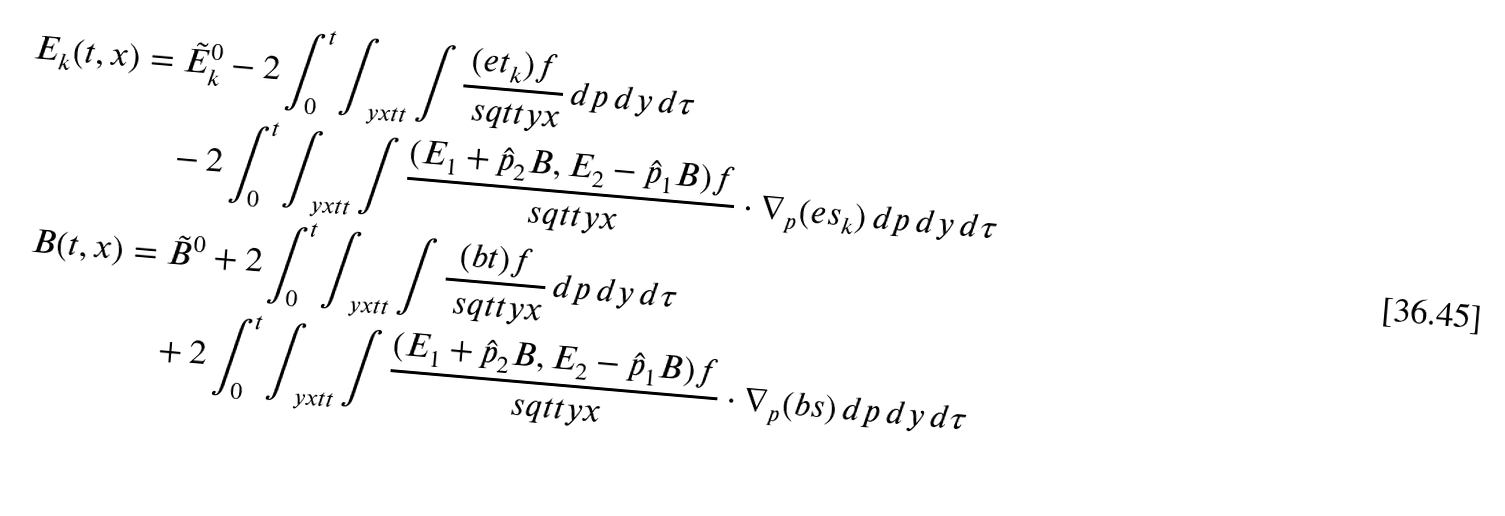<formula> <loc_0><loc_0><loc_500><loc_500>E _ { k } ( t , x ) & = \tilde { E } ^ { 0 } _ { k } - 2 \int ^ { t } _ { 0 } \int _ { \ y x t t } \int \frac { ( e t _ { k } ) f } { \ s q t t y x } \, d p \, d y \, d \tau \\ & \quad - 2 \int ^ { t } _ { 0 } \int _ { \ y x t t } \int \frac { ( E _ { 1 } + \hat { p } _ { 2 } B , E _ { 2 } - \hat { p } _ { 1 } B ) f } { \ s q t t y x } \cdot \nabla _ { p } ( e s _ { k } ) \, d p \, d y \, d \tau \\ B ( t , x ) & = \tilde { B } ^ { 0 } + 2 \int ^ { t } _ { 0 } \int _ { \ y x t t } \int \frac { ( b t ) f } { \ s q t t y x } \, d p \, d y \, d \tau \\ & \quad + 2 \int ^ { t } _ { 0 } \int _ { \ y x t t } \int \frac { ( E _ { 1 } + \hat { p } _ { 2 } B , E _ { 2 } - \hat { p } _ { 1 } B ) f } { \ s q t t y x } \cdot \nabla _ { p } ( b s ) \, d p \, d y \, d \tau</formula> 